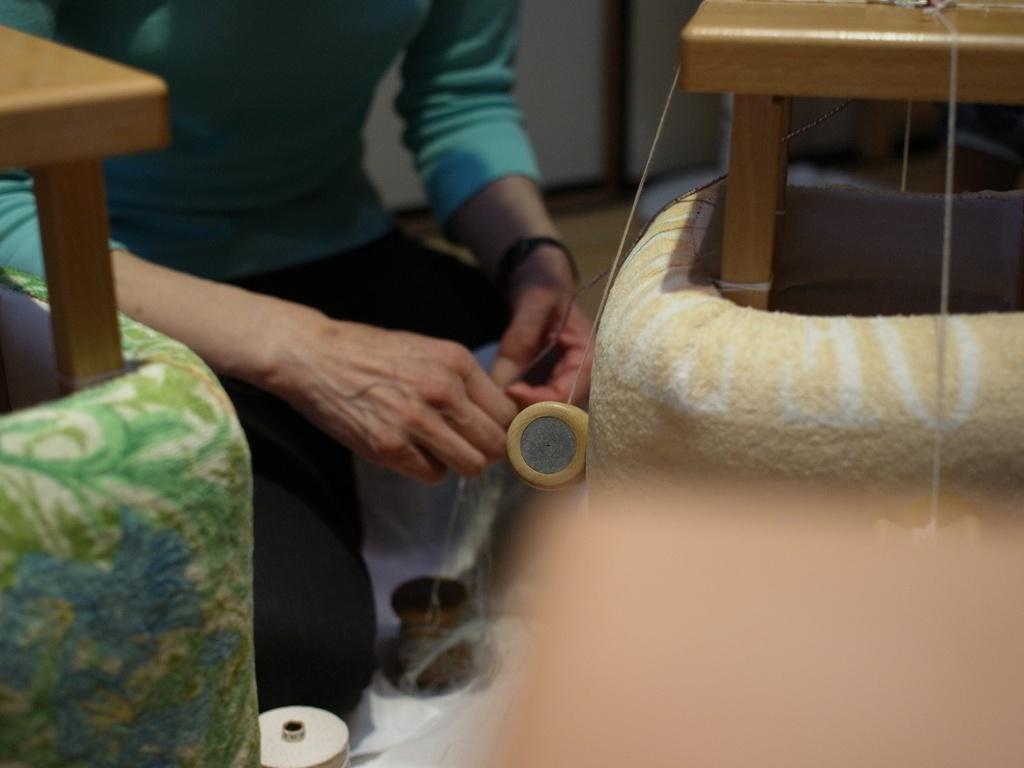Please provide a concise description of this image. In this picture I can observe a person. There are brown colored stools on either sides of the picture. The background is blurred. 